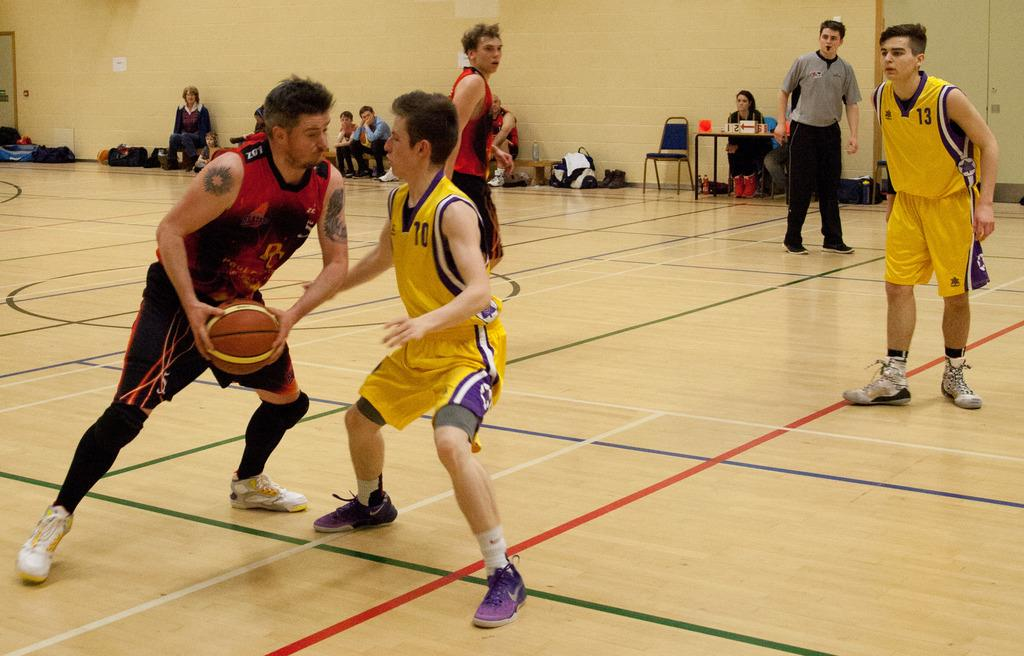What activity are the players engaged in within the image? The players are playing basketball in the image. Are there any spectators present in the image? Yes, there are people sitting on the side in the image. What type of structure can be seen in the background? There is a wall visible in the image. What type of quiver can be seen on the players' backs in the image? There is no quiver present on the players' backs in the image, as they are playing basketball and not using any archery equipment. 